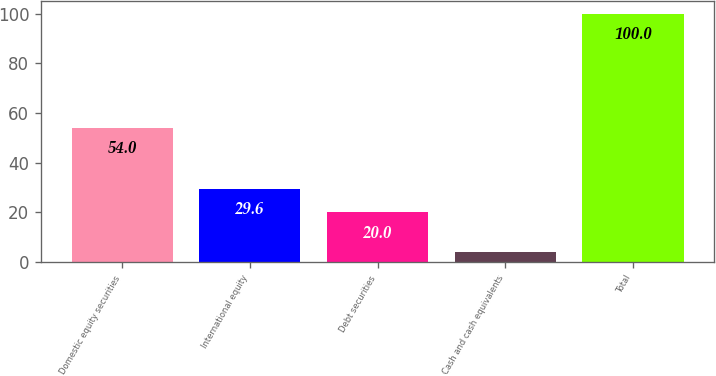Convert chart. <chart><loc_0><loc_0><loc_500><loc_500><bar_chart><fcel>Domestic equity securities<fcel>International equity<fcel>Debt securities<fcel>Cash and cash equivalents<fcel>Total<nl><fcel>54<fcel>29.6<fcel>20<fcel>4<fcel>100<nl></chart> 